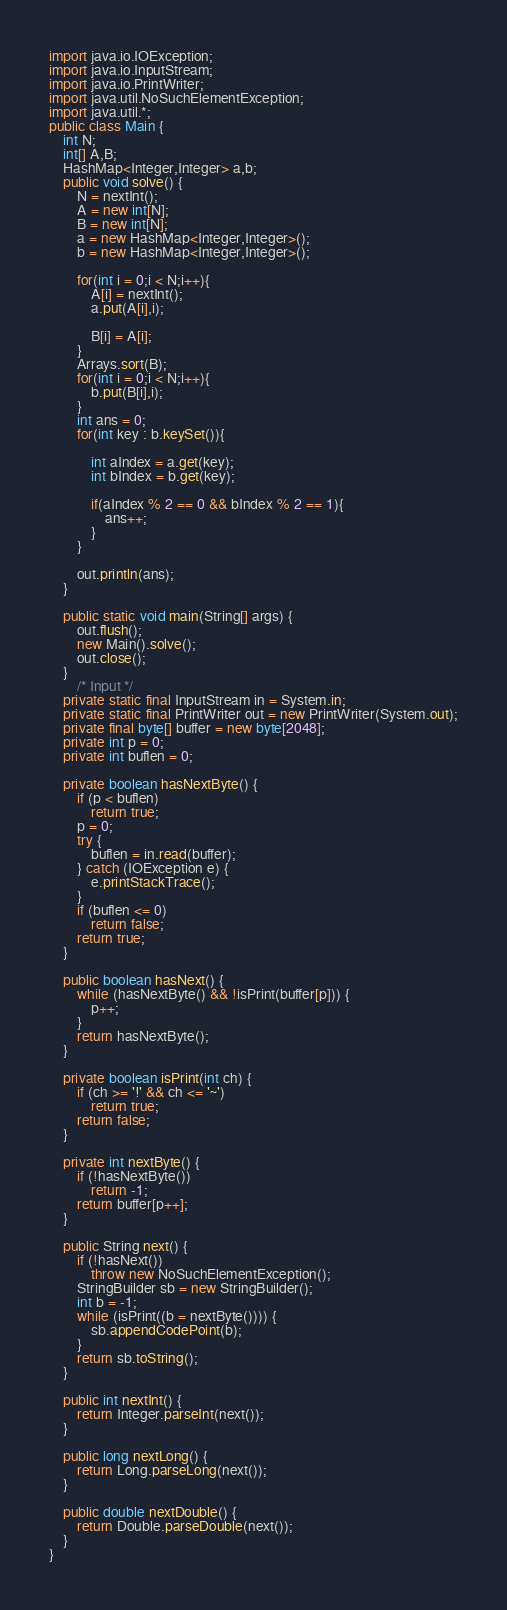Convert code to text. <code><loc_0><loc_0><loc_500><loc_500><_Java_>import java.io.IOException;
import java.io.InputStream;
import java.io.PrintWriter;
import java.util.NoSuchElementException;
import java.util.*;
public class Main {
	int N;
	int[] A,B;
	HashMap<Integer,Integer> a,b;
    public void solve() {
		N = nextInt();
		A = new int[N];
		B = new int[N];
		a = new HashMap<Integer,Integer>();
		b = new HashMap<Integer,Integer>();
		
		for(int i = 0;i < N;i++){
			A[i] = nextInt();
			a.put(A[i],i);
			
			B[i] = A[i];
		}
		Arrays.sort(B);
		for(int i = 0;i < N;i++){
			b.put(B[i],i);
		}
		int ans = 0;
		for(int key : b.keySet()){
			
			int aIndex = a.get(key);
			int bIndex = b.get(key);
			
			if(aIndex % 2 == 0 && bIndex % 2 == 1){
				ans++;
			}
		}
		
		out.println(ans);
    }
 
	public static void main(String[] args) {
		out.flush();
		new Main().solve();
		out.close();
	}
		/* Input */
	private static final InputStream in = System.in;
	private static final PrintWriter out = new PrintWriter(System.out);
	private final byte[] buffer = new byte[2048];
	private int p = 0;
	private int buflen = 0;

	private boolean hasNextByte() {
		if (p < buflen)
			return true;
		p = 0;
		try {
			buflen = in.read(buffer);
		} catch (IOException e) {
			e.printStackTrace();
		}
		if (buflen <= 0)
			return false;
		return true;
	}

	public boolean hasNext() {
		while (hasNextByte() && !isPrint(buffer[p])) {
			p++;
		}
		return hasNextByte();
	}

	private boolean isPrint(int ch) {
		if (ch >= '!' && ch <= '~')
			return true;
		return false;
	}

	private int nextByte() {
		if (!hasNextByte())
			return -1;
		return buffer[p++];
	}

	public String next() {
		if (!hasNext())
			throw new NoSuchElementException();
		StringBuilder sb = new StringBuilder();
		int b = -1;
		while (isPrint((b = nextByte()))) {
			sb.appendCodePoint(b);
		}
		return sb.toString();
	}

	public int nextInt() {
		return Integer.parseInt(next());
	}

	public long nextLong() {
		return Long.parseLong(next());
	}

	public double nextDouble() {
		return Double.parseDouble(next());
	}
}</code> 